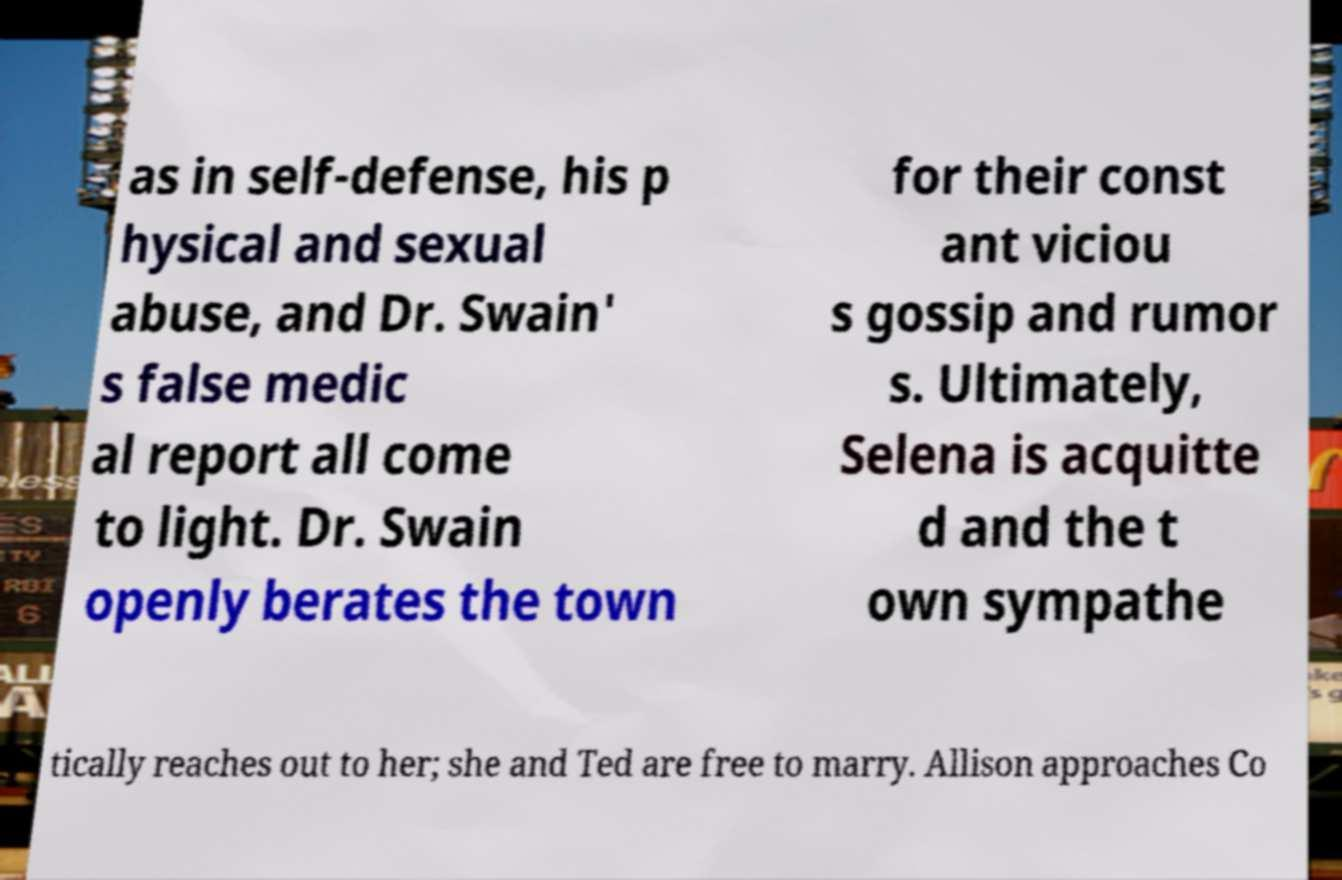Can you read and provide the text displayed in the image?This photo seems to have some interesting text. Can you extract and type it out for me? as in self-defense, his p hysical and sexual abuse, and Dr. Swain' s false medic al report all come to light. Dr. Swain openly berates the town for their const ant viciou s gossip and rumor s. Ultimately, Selena is acquitte d and the t own sympathe tically reaches out to her; she and Ted are free to marry. Allison approaches Co 